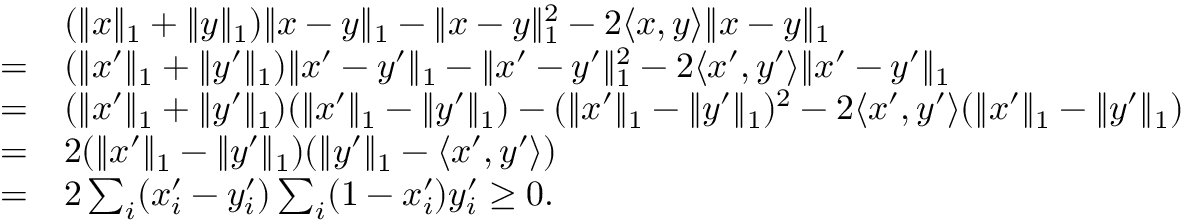<formula> <loc_0><loc_0><loc_500><loc_500>\begin{array} { r l } & { ( \| x \| _ { 1 } + \| y \| _ { 1 } ) \| x - y \| _ { 1 } - \| x - y \| _ { 1 } ^ { 2 } - 2 \langle x , y \rangle \| x - y \| _ { 1 } } \\ { = } & { ( \| x ^ { \prime } \| _ { 1 } + \| y ^ { \prime } \| _ { 1 } ) \| x ^ { \prime } - y ^ { \prime } \| _ { 1 } - \| x ^ { \prime } - y ^ { \prime } \| _ { 1 } ^ { 2 } - 2 \langle x ^ { \prime } , y ^ { \prime } \rangle \| x ^ { \prime } - y ^ { \prime } \| _ { 1 } } \\ { = } & { ( \| x ^ { \prime } \| _ { 1 } + \| y ^ { \prime } \| _ { 1 } ) ( \| x ^ { \prime } \| _ { 1 } - \| y ^ { \prime } \| _ { 1 } ) - ( \| x ^ { \prime } \| _ { 1 } - \| y ^ { \prime } \| _ { 1 } ) ^ { 2 } - 2 \langle x ^ { \prime } , y ^ { \prime } \rangle ( \| x ^ { \prime } \| _ { 1 } - \| y ^ { \prime } \| _ { 1 } ) } \\ { = } & { 2 ( \| x ^ { \prime } \| _ { 1 } - \| y ^ { \prime } \| _ { 1 } ) ( \| y ^ { \prime } \| _ { 1 } - \langle x ^ { \prime } , y ^ { \prime } \rangle ) } \\ { = } & { 2 \sum _ { i } ( x _ { i } ^ { \prime } - y _ { i } ^ { \prime } ) \sum _ { i } ( 1 - x _ { i } ^ { \prime } ) y _ { i } ^ { \prime } \geq 0 . } \end{array}</formula> 